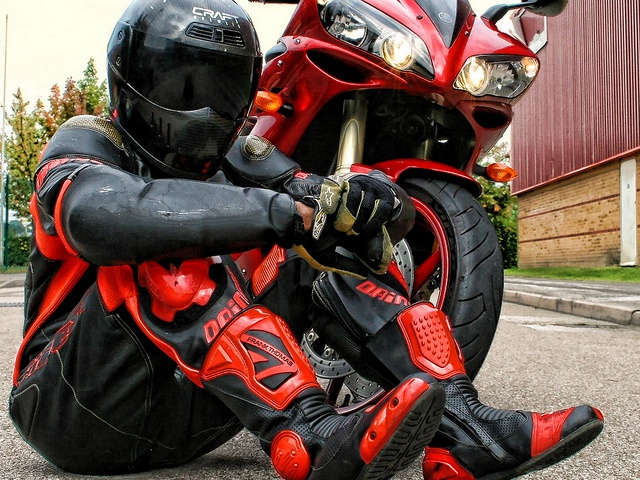Describe the objects in this image and their specific colors. I can see people in beige, black, gray, red, and brown tones and motorcycle in ivory, black, maroon, and gray tones in this image. 